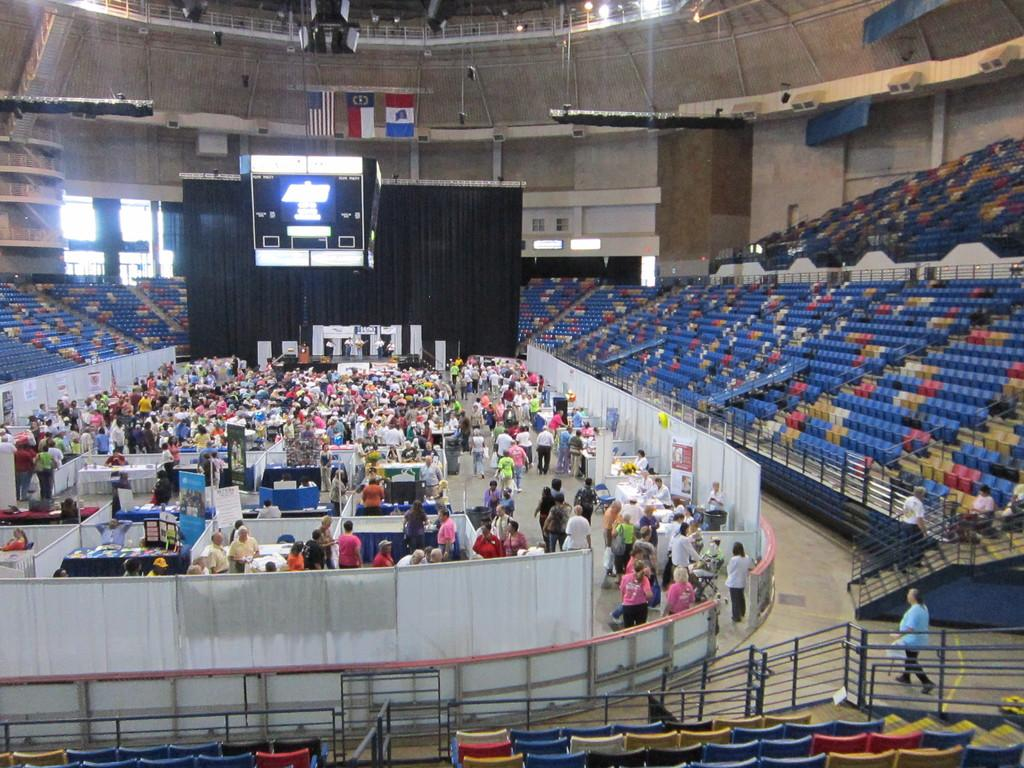What is happening in the image? There are persons standing in the image. What else can be seen in the image besides the persons? There are other objects beside the persons, as well as televisions above them and empty chairs around them. What type of payment is being made for the soda in the image? There is no soda present in the image, so no payment can be made for it. 